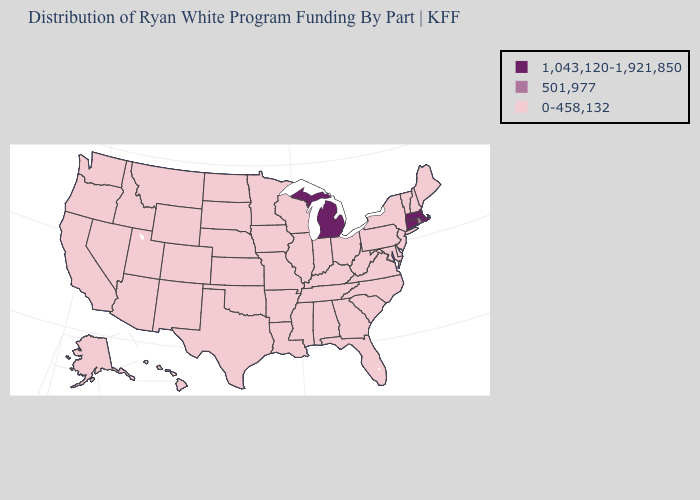Does California have a lower value than Connecticut?
Answer briefly. Yes. What is the value of Maryland?
Be succinct. 0-458,132. Does the first symbol in the legend represent the smallest category?
Be succinct. No. Name the states that have a value in the range 1,043,120-1,921,850?
Concise answer only. Connecticut, Massachusetts, Michigan. What is the value of Missouri?
Answer briefly. 0-458,132. Name the states that have a value in the range 0-458,132?
Give a very brief answer. Alabama, Alaska, Arizona, Arkansas, California, Colorado, Delaware, Florida, Georgia, Hawaii, Idaho, Illinois, Indiana, Iowa, Kansas, Kentucky, Louisiana, Maine, Maryland, Minnesota, Mississippi, Missouri, Montana, Nebraska, Nevada, New Hampshire, New Jersey, New Mexico, New York, North Carolina, North Dakota, Ohio, Oklahoma, Oregon, Pennsylvania, South Carolina, South Dakota, Tennessee, Texas, Utah, Vermont, Virginia, Washington, West Virginia, Wisconsin, Wyoming. What is the value of Pennsylvania?
Short answer required. 0-458,132. Does the map have missing data?
Keep it brief. No. What is the value of Georgia?
Be succinct. 0-458,132. Name the states that have a value in the range 501,977?
Quick response, please. Rhode Island. How many symbols are there in the legend?
Concise answer only. 3. What is the value of New York?
Quick response, please. 0-458,132. What is the value of Rhode Island?
Write a very short answer. 501,977. Name the states that have a value in the range 0-458,132?
Answer briefly. Alabama, Alaska, Arizona, Arkansas, California, Colorado, Delaware, Florida, Georgia, Hawaii, Idaho, Illinois, Indiana, Iowa, Kansas, Kentucky, Louisiana, Maine, Maryland, Minnesota, Mississippi, Missouri, Montana, Nebraska, Nevada, New Hampshire, New Jersey, New Mexico, New York, North Carolina, North Dakota, Ohio, Oklahoma, Oregon, Pennsylvania, South Carolina, South Dakota, Tennessee, Texas, Utah, Vermont, Virginia, Washington, West Virginia, Wisconsin, Wyoming. 